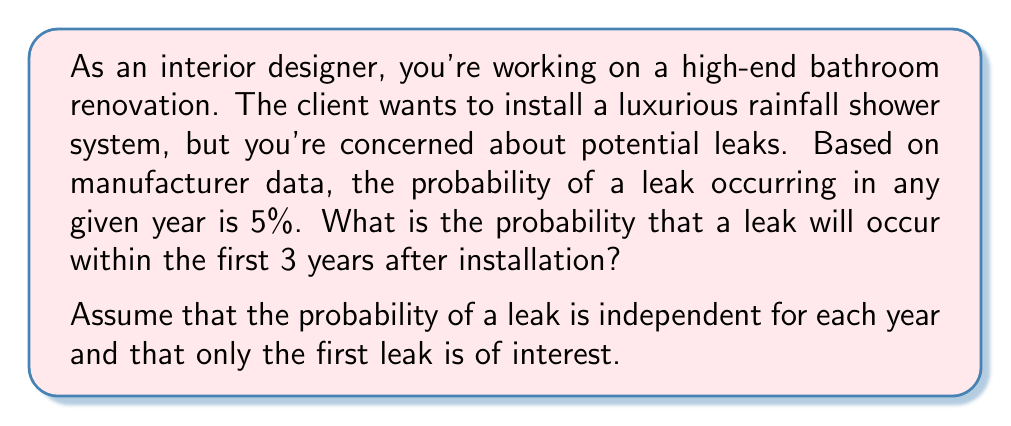Teach me how to tackle this problem. Let's approach this step-by-step:

1) First, let's define our events:
   Let A be the event "a leak occurs within the first 3 years"

2) It's easier to calculate the probability of no leaks occurring in 3 years, then subtract this from 1 to get the probability of at least one leak.

3) The probability of no leak in one year is:
   $P(\text{no leak in 1 year}) = 1 - 0.05 = 0.95$

4) For no leaks in 3 years, we need this to happen 3 times in a row. Since the events are independent, we multiply the probabilities:
   $P(\text{no leak in 3 years}) = 0.95 \times 0.95 \times 0.95 = 0.95^3$

5) Now we can calculate:
   $P(A) = 1 - P(\text{no leak in 3 years})$
   $P(A) = 1 - 0.95^3$

6) Let's compute this:
   $P(A) = 1 - 0.95^3 = 1 - 0.857375 = 0.142625$

7) Converting to a percentage:
   $0.142625 \times 100\% = 14.2625\%$

Therefore, the probability of a leak occurring within the first 3 years is approximately 14.26%.
Answer: 14.26% 